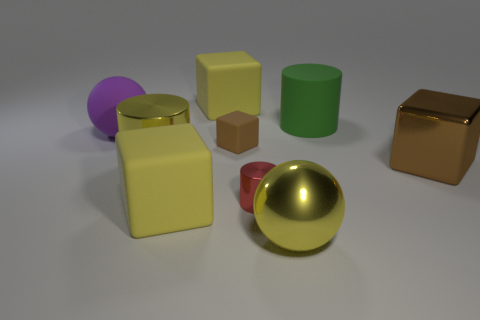Subtract all yellow shiny cylinders. How many cylinders are left? 2 Subtract all yellow cylinders. How many brown blocks are left? 2 Add 1 large purple spheres. How many objects exist? 10 Subtract all purple cylinders. Subtract all gray blocks. How many cylinders are left? 3 Subtract all balls. How many objects are left? 7 Add 1 red rubber balls. How many red rubber balls exist? 1 Subtract 0 cyan cylinders. How many objects are left? 9 Subtract all small brown blocks. Subtract all tiny gray matte spheres. How many objects are left? 8 Add 5 tiny shiny cylinders. How many tiny shiny cylinders are left? 6 